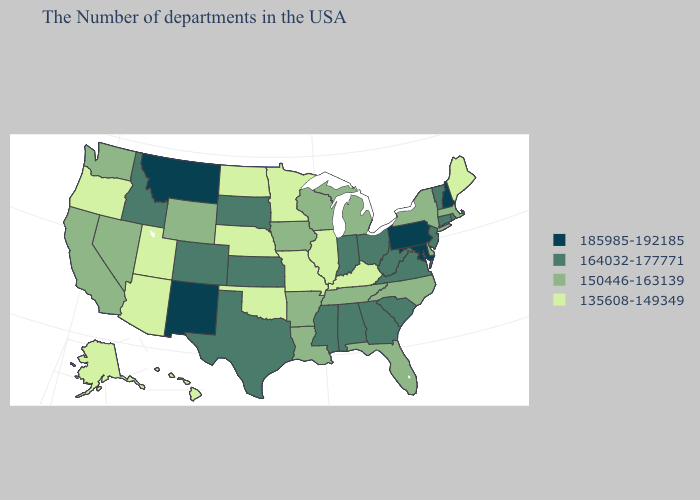Does Pennsylvania have the highest value in the Northeast?
Concise answer only. Yes. Name the states that have a value in the range 185985-192185?
Short answer required. New Hampshire, Maryland, Pennsylvania, New Mexico, Montana. Among the states that border Colorado , which have the highest value?
Give a very brief answer. New Mexico. Name the states that have a value in the range 185985-192185?
Give a very brief answer. New Hampshire, Maryland, Pennsylvania, New Mexico, Montana. Does the map have missing data?
Give a very brief answer. No. What is the lowest value in states that border Wyoming?
Concise answer only. 135608-149349. Does California have the highest value in the West?
Write a very short answer. No. How many symbols are there in the legend?
Be succinct. 4. What is the highest value in the USA?
Give a very brief answer. 185985-192185. What is the lowest value in the USA?
Be succinct. 135608-149349. Which states have the lowest value in the South?
Keep it brief. Kentucky, Oklahoma. Among the states that border Missouri , which have the highest value?
Be succinct. Kansas. What is the value of South Carolina?
Write a very short answer. 164032-177771. Which states hav the highest value in the West?
Concise answer only. New Mexico, Montana. Name the states that have a value in the range 185985-192185?
Answer briefly. New Hampshire, Maryland, Pennsylvania, New Mexico, Montana. 